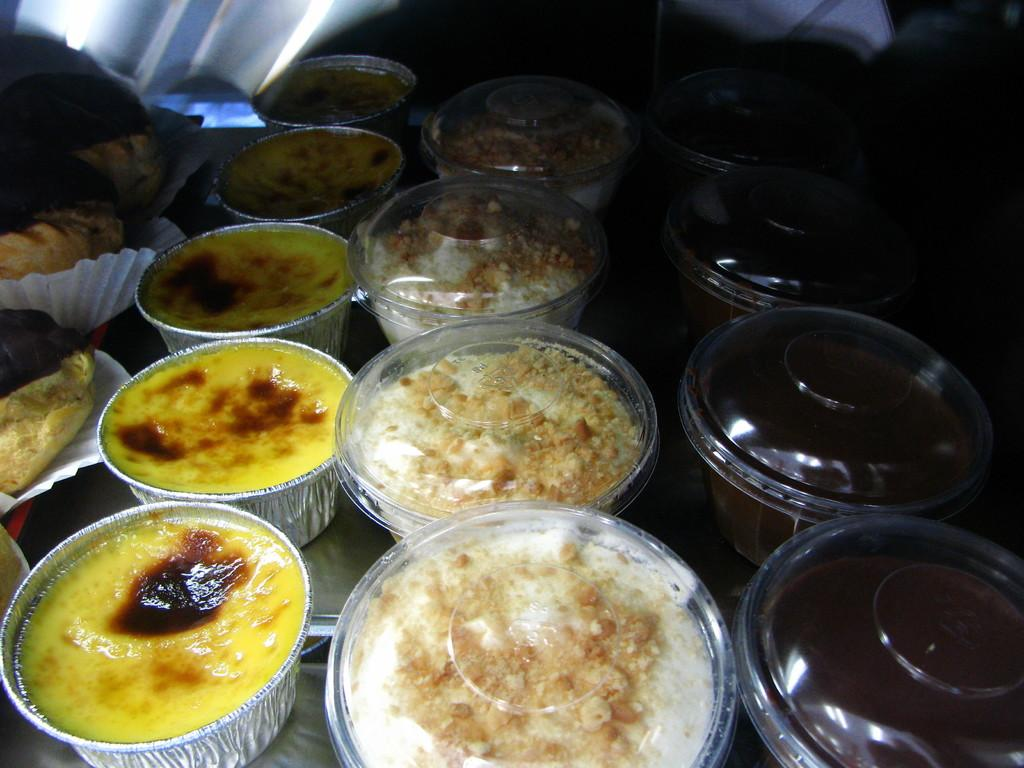What can be seen in the bowls in the image? There are food items in the bowls in the image. Can you describe the background of the image? The background of the image is dark. What type of mitten is being used to paint on the canvas in the image? There is no mitten or canvas present in the image; it only features bowls with food items and a dark background. 